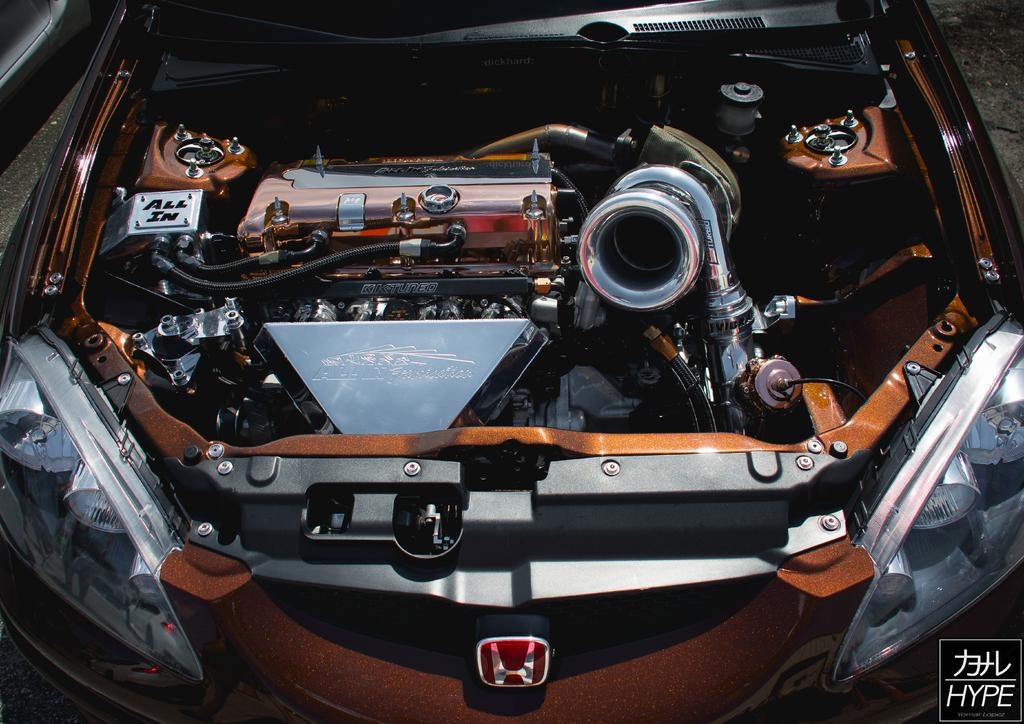What is the main subject of the image? There is a car in the center of the image. What type of guitar can be seen in the car's trunk in the image? There is no guitar present in the image; it only features a car in the center. 